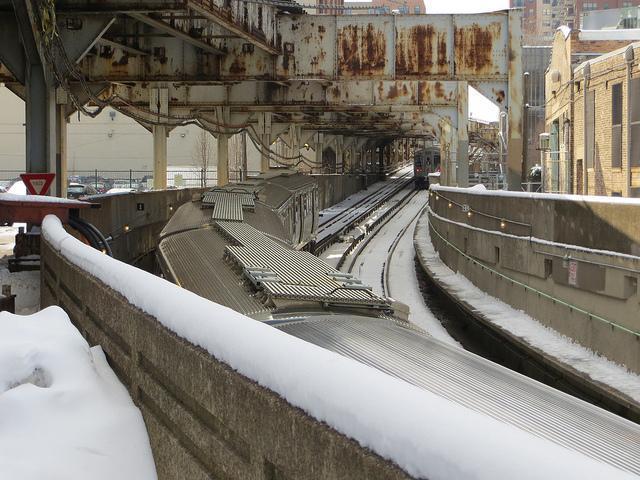What is located above the ironwork on top of the train that is heading away?
Indicate the correct response by choosing from the four available options to answer the question.
Options: Coffee shop, factory, storefront, train track. Train track. 